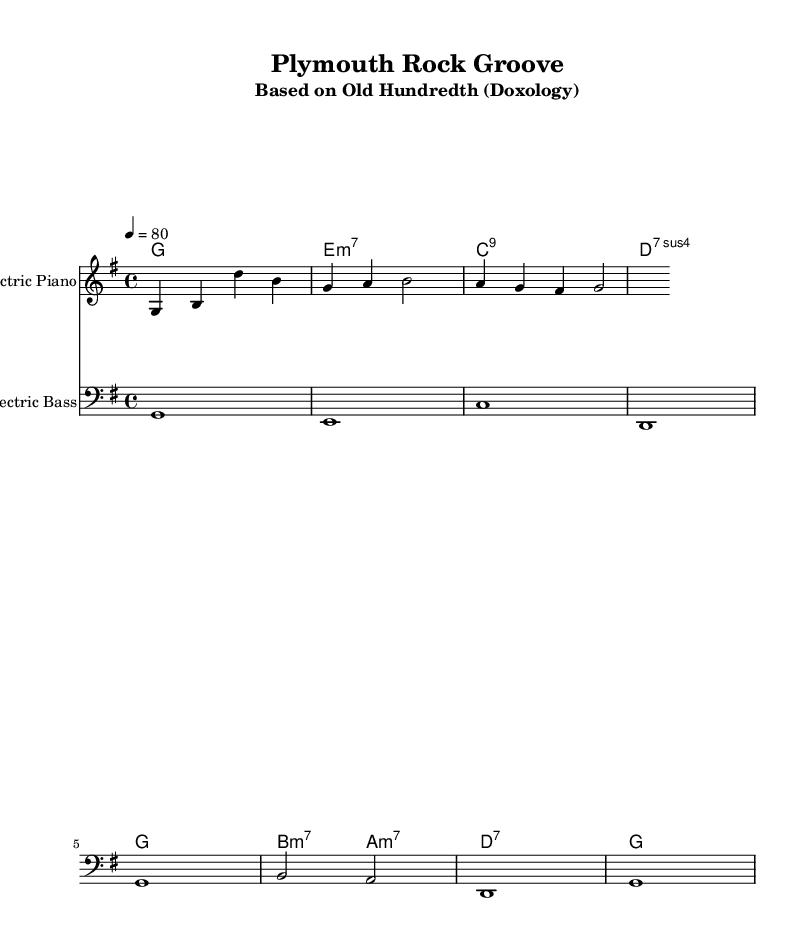What is the key signature of this music? The key signature is G major, which has one sharp (F#). This can be determined from the 'key g \major' notation in the global lyrics section of the code.
Answer: G major What is the time signature of this music? The time signature is 4/4, indicated by '\time 4/4' in the global section of the code. This means there are four beats in each measure and a quarter note receives one beat.
Answer: 4/4 What is the tempo marking for this piece? The tempo is marked at 80 beats per minute, specified by '4 = 80' in the tempo setting within the global section of the code.
Answer: 80 What instrument plays the melody? The melody is played by the "Electric Piano," as specified in the 'instrumentName' field of the staff section for melody.
Answer: Electric Piano How many measures are in the melody section? The melody section consists of four measures, which can be counted from the notations provided in the melody relative. Each line in the music displays a different measure.
Answer: Four What kind of chords are predominantly used in the harmonies section? The harmonies section predominantly uses seventh chords, as most of the chords have a '7' or '7sus4' designation indicating they are seventh chords.
Answer: Seventh chords What is the last note played in the bass section? The last note played in the bass section is 'g', which is the final note shown in the bass notation relative at the end of its line.
Answer: g 